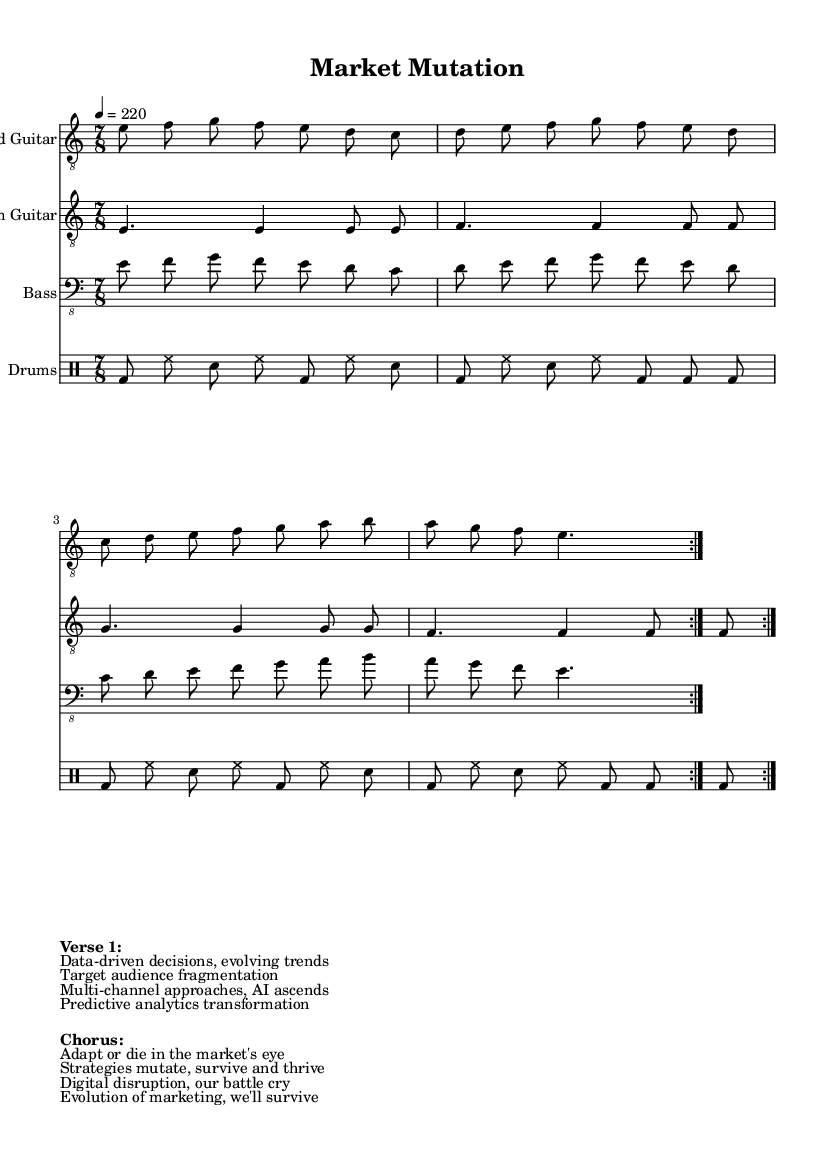What is the key signature of this music? The key signature is indicated by the symbol at the beginning of the staff, which shows that it is E Phrygian. Phrygian is a mode derived from the third degree of the major scale and typically features a minor second interval. In this case, it involves the notes E, F, G, A, B, C, and D.
Answer: E Phrygian What is the time signature of this music? The time signature appears in the form of a fraction at the beginning of the piece, which is written as 7/8. This indicates that there are seven beats in each measure and an eighth note receives one beat.
Answer: 7/8 What is the tempo marking of this music? The tempo is notated above the staff as a metronome marking, specifically stating '4 = 220'. This means the piece should be played at a tempo of 220 beats per minute, with the quarter note (4) as the reference beat.
Answer: 220 How many times is the lead guitar section repeated? The lead guitar section indicates a repeat sign, which specifies that the passage should be played two times in succession. The text "volta 2" indicates this specifically for that part.
Answer: 2 What is the main theme reflected in the lyrics? The lyrics suggest a theme focused on evolution in marketing strategies, mentioning concepts such as data-driven decisions and digital disruption. This thematic content aligns with the general attributes of technical death metal, which often addresses complex and abstract themes.
Answer: Evolution of marketing What instrument is featured as the lead role in this piece? The lead role is indicated by the staff labeled "Lead Guitar," which is typically responsible for the melodic line in metal music, showcasing higher range and technical solos. This is commonly seen in technical death metal bands.
Answer: Lead Guitar What does the phrase "Digital disruption" signify in the context of the lyrics? In marketing and business, "Digital disruption" refers to the change that results from new digital technologies and business models. It represents a significant shift that alters how companies operate, and the phrase adds depth to the narrative of evolving marketing strategies in the lyrics.
Answer: Change 